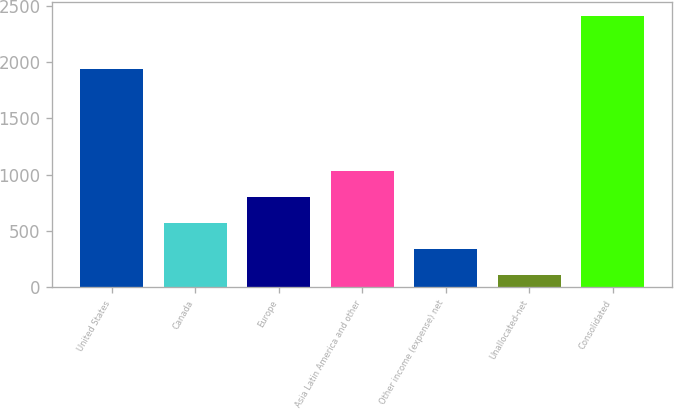<chart> <loc_0><loc_0><loc_500><loc_500><bar_chart><fcel>United States<fcel>Canada<fcel>Europe<fcel>Asia Latin America and other<fcel>Other income (expense) net<fcel>Unallocated-net<fcel>Consolidated<nl><fcel>1942.9<fcel>568.8<fcel>799.25<fcel>1029.7<fcel>338.35<fcel>107.9<fcel>2412.4<nl></chart> 